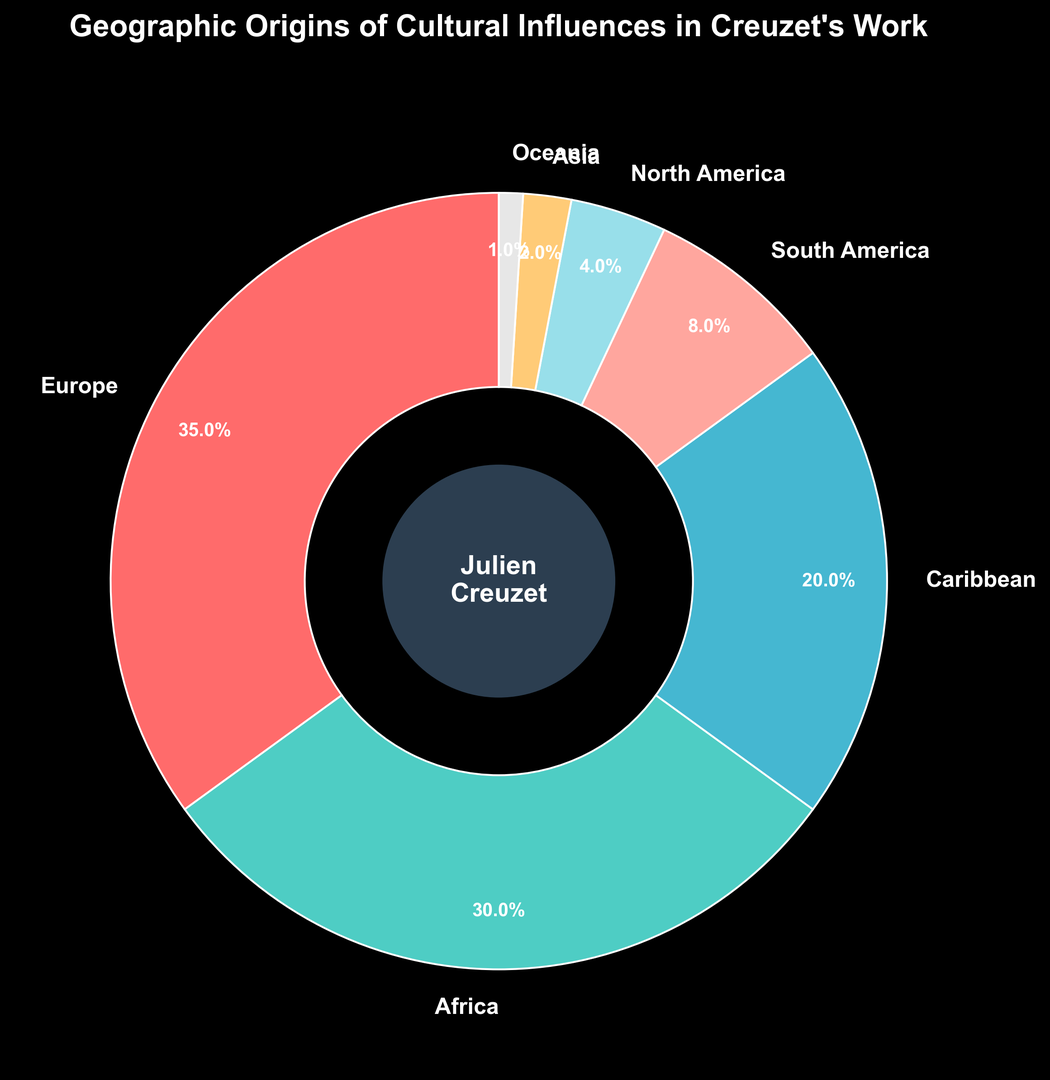What is the largest geographic influence in Creuzet's work? The largest segment of the ring chart represents Europe, which is labeled with 35%.
Answer: Europe Which two continents have the largest combined influence? The two largest segments are Europe with 35% and Africa with 30%. Adding these yields: 35% + 30% = 65%.
Answer: Europe and Africa Which continent has the smallest influence on Creuzet's work? The smallest segment of the ring chart is labeled as Oceania with 1%.
Answer: Oceania Is the influence from North America larger or smaller than that from South America? North America has 4% influence, while South America has 8%. Since 4% is less than 8%, North America's influence is smaller.
Answer: Smaller What is the total percentage of influence from continents outside of Europe and Africa? Adding the percentages of the continents excluding Europe and Africa: Caribbean 20% + South America 8% + North America 4% + Asia 2% + Oceania 1% = 35%.
Answer: 35% How much greater is European influence compared to Caribbean influence? The European influence is 35%, and the Caribbean influence is 20%. The difference is: 35% - 20% = 15%.
Answer: 15% Which regions combined contribute less than 10% to Creuzet's cultural influences? The regions are Asia with 2%, Oceania with 1%, and North America with 4%. Adding these up: 2% + 1% + 4% = 7%, which is less than 10%.
Answer: Asia and Oceania How does the influence of the Caribbean compare to that of Africa? The Caribbean has a 20% influence, while Africa has a 30% influence. Since 20% is less than 30%, the Caribbean influence is less.
Answer: Less What visual elements indicate Julien Creuzet is the central focus of the influence chart? The central circle features Julien Creuzet's name in bold text, surrounded by the segmented ring chart, making him the focal point.
Answer: Central circle with name If the total influence is 100%, what would the percentage increase in Caribbean influence be if it doubled? The current Caribbean influence is 20%. Doubling it would be: 20% × 2 = 40%. The increase would be: 40% - 20% = 20%.
Answer: 20% If Creuzet's influences from Asia and Africa combined had doubled, what would be the new influence percentage for Asia and Africa? Asia currently is 2%, and Africa is 30%. Combined influence is 32%. If doubled: 32% × 2 = 64%.
Answer: 64% 